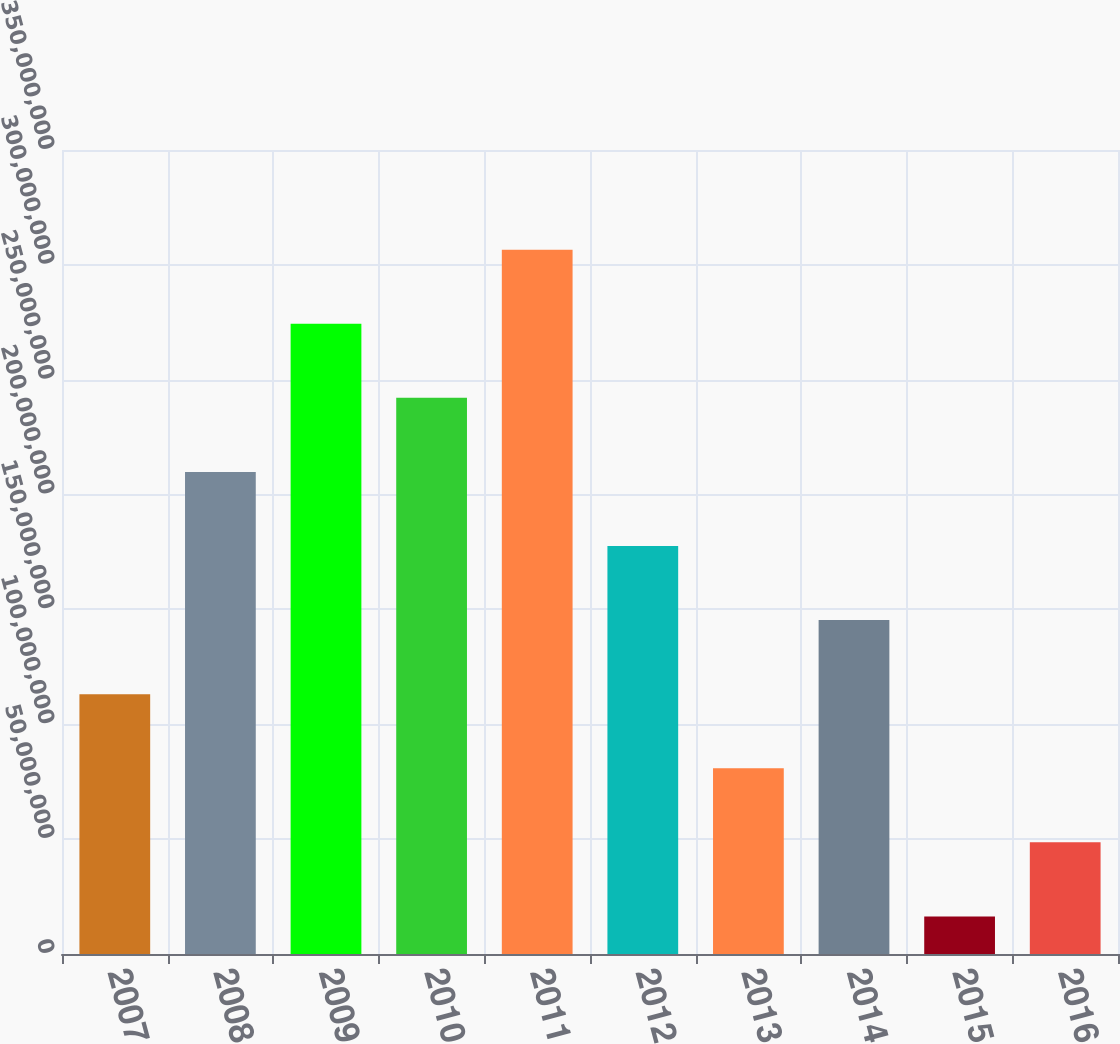<chart> <loc_0><loc_0><loc_500><loc_500><bar_chart><fcel>2007<fcel>2008<fcel>2009<fcel>2010<fcel>2011<fcel>2012<fcel>2013<fcel>2014<fcel>2015<fcel>2016<nl><fcel>1.13108e+08<fcel>2.09856e+08<fcel>2.74354e+08<fcel>2.42105e+08<fcel>3.06604e+08<fcel>1.77606e+08<fcel>8.08586e+07<fcel>1.45357e+08<fcel>1.636e+07<fcel>4.86093e+07<nl></chart> 